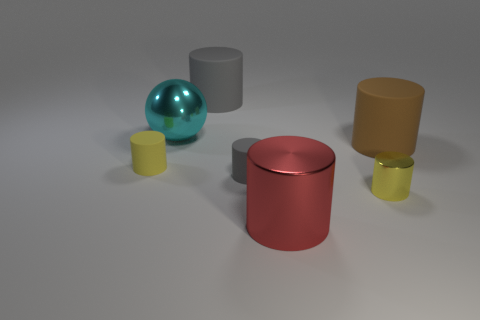Subtract all blue cylinders. Subtract all cyan spheres. How many cylinders are left? 6 Subtract all purple cylinders. How many blue balls are left? 0 Add 2 tiny yellows. How many large things exist? 0 Subtract all large purple rubber cylinders. Subtract all gray matte cylinders. How many objects are left? 5 Add 5 tiny gray cylinders. How many tiny gray cylinders are left? 6 Add 1 metallic balls. How many metallic balls exist? 2 Add 3 big purple metallic things. How many objects exist? 10 Subtract all gray cylinders. How many cylinders are left? 4 Subtract all large red cylinders. How many cylinders are left? 5 Subtract 0 gray balls. How many objects are left? 7 